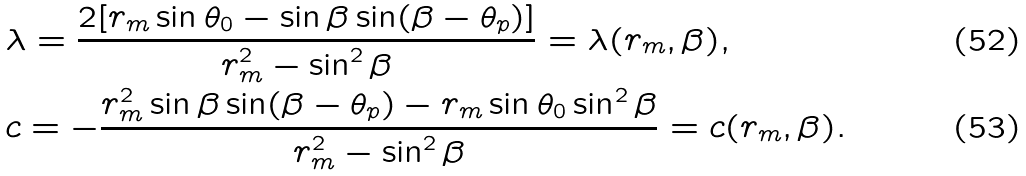<formula> <loc_0><loc_0><loc_500><loc_500>& \lambda = \frac { 2 [ r _ { m } \sin \theta _ { 0 } - \sin \beta \sin ( \beta - \theta _ { p } ) ] } { r _ { m } ^ { 2 } - \sin ^ { 2 } \beta } = \lambda ( r _ { m } , \beta ) , \\ & c = - \frac { r _ { m } ^ { 2 } \sin \beta \sin ( \beta - \theta _ { p } ) - r _ { m } \sin \theta _ { 0 } \sin ^ { 2 } \beta } { r _ { m } ^ { 2 } - \sin ^ { 2 } \beta } = c ( r _ { m } , \beta ) .</formula> 